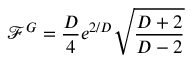Convert formula to latex. <formula><loc_0><loc_0><loc_500><loc_500>\mathcal { F } ^ { G } = \frac { D } { 4 } e ^ { 2 / D } \sqrt { \frac { D + 2 } { D - 2 } }</formula> 